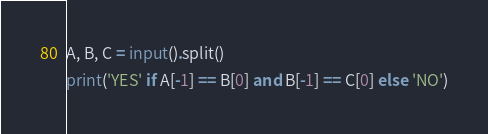<code> <loc_0><loc_0><loc_500><loc_500><_Python_>A, B, C = input().split()
print('YES' if A[-1] == B[0] and B[-1] == C[0] else 'NO')
</code> 